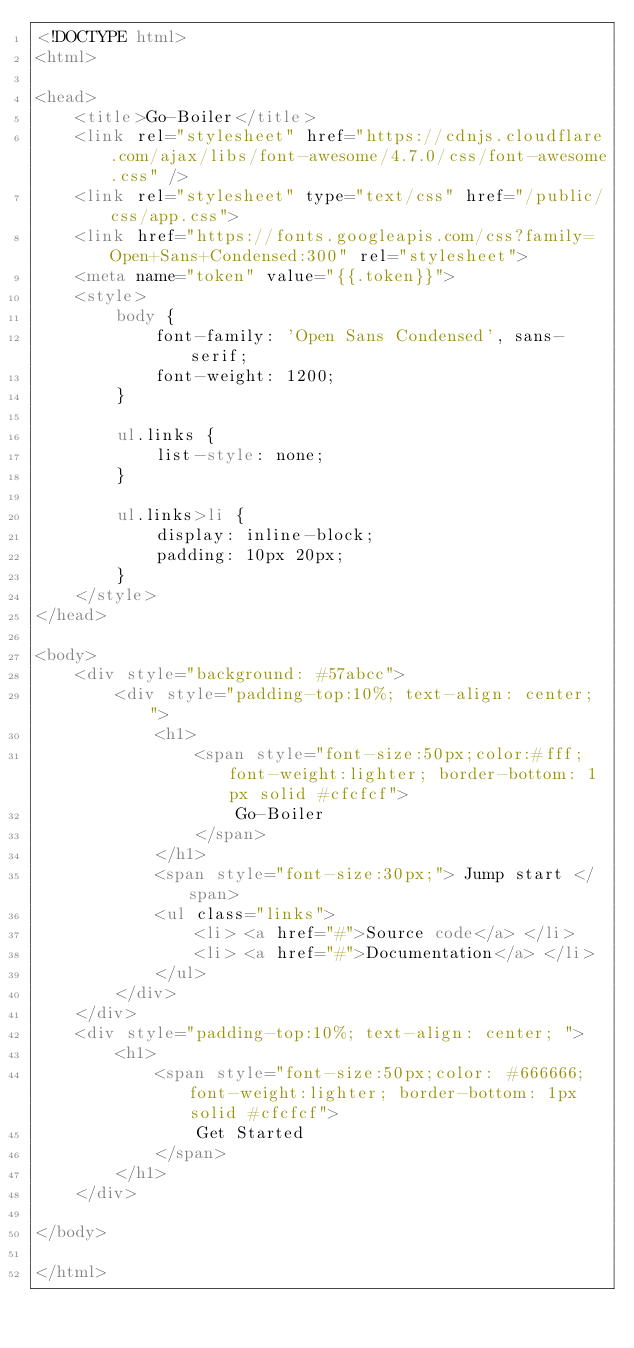Convert code to text. <code><loc_0><loc_0><loc_500><loc_500><_HTML_><!DOCTYPE html>
<html>

<head>
	<title>Go-Boiler</title>
	<link rel="stylesheet" href="https://cdnjs.cloudflare.com/ajax/libs/font-awesome/4.7.0/css/font-awesome.css" />
	<link rel="stylesheet" type="text/css" href="/public/css/app.css">
	<link href="https://fonts.googleapis.com/css?family=Open+Sans+Condensed:300" rel="stylesheet">
	<meta name="token" value="{{.token}}">
	<style>
		body {
			font-family: 'Open Sans Condensed', sans-serif;
			font-weight: 1200;
		}

		ul.links {
			list-style: none;
		}

		ul.links>li {
			display: inline-block;
			padding: 10px 20px;
		}
	</style>
</head>

<body>
	<div style="background: #57abcc">
		<div style="padding-top:10%; text-align: center; ">
			<h1>
				<span style="font-size:50px;color:#fff; font-weight:lighter; border-bottom: 1px solid #cfcfcf">
					Go-Boiler
				</span>
			</h1>
			<span style="font-size:30px;"> Jump start </span>
			<ul class="links">
				<li> <a href="#">Source code</a> </li>
				<li> <a href="#">Documentation</a> </li>
			</ul>
		</div>
	</div>
	<div style="padding-top:10%; text-align: center; ">
		<h1>
			<span style="font-size:50px;color: #666666; font-weight:lighter; border-bottom: 1px solid #cfcfcf">
				Get Started
			</span>
		</h1>
	</div>

</body>

</html></code> 